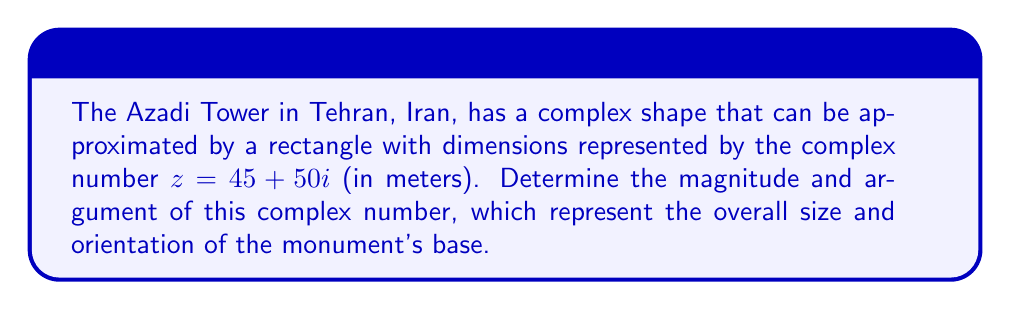Help me with this question. To find the magnitude and argument of the complex number $z = 45 + 50i$, we'll follow these steps:

1. Magnitude calculation:
   The magnitude of a complex number $z = a + bi$ is given by:
   $$|z| = \sqrt{a^2 + b^2}$$
   
   For $z = 45 + 50i$:
   $$|z| = \sqrt{45^2 + 50^2} = \sqrt{2025 + 2500} = \sqrt{4525} \approx 67.27$$

2. Argument calculation:
   The argument of a complex number is the angle it makes with the positive real axis, calculated using:
   $$\arg(z) = \tan^{-1}\left(\frac{b}{a}\right)$$
   
   For $z = 45 + 50i$:
   $$\arg(z) = \tan^{-1}\left(\frac{50}{45}\right) \approx 0.8391$$

   Note: This result is in radians. To convert to degrees, multiply by $\frac{180}{\pi}$:
   $$0.8391 \times \frac{180}{\pi} \approx 48.09°$$

The magnitude represents the diagonal length of the rectangular base, while the argument represents the angle this diagonal makes with the horizontal axis.
Answer: Magnitude: $67.27$ m, Argument: $0.8391$ rad or $48.09°$ 